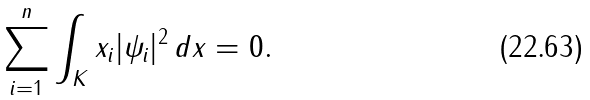Convert formula to latex. <formula><loc_0><loc_0><loc_500><loc_500>\sum _ { i = 1 } ^ { n } \int _ { K } x _ { i } | \psi _ { i } | ^ { 2 } \, d x = 0 .</formula> 